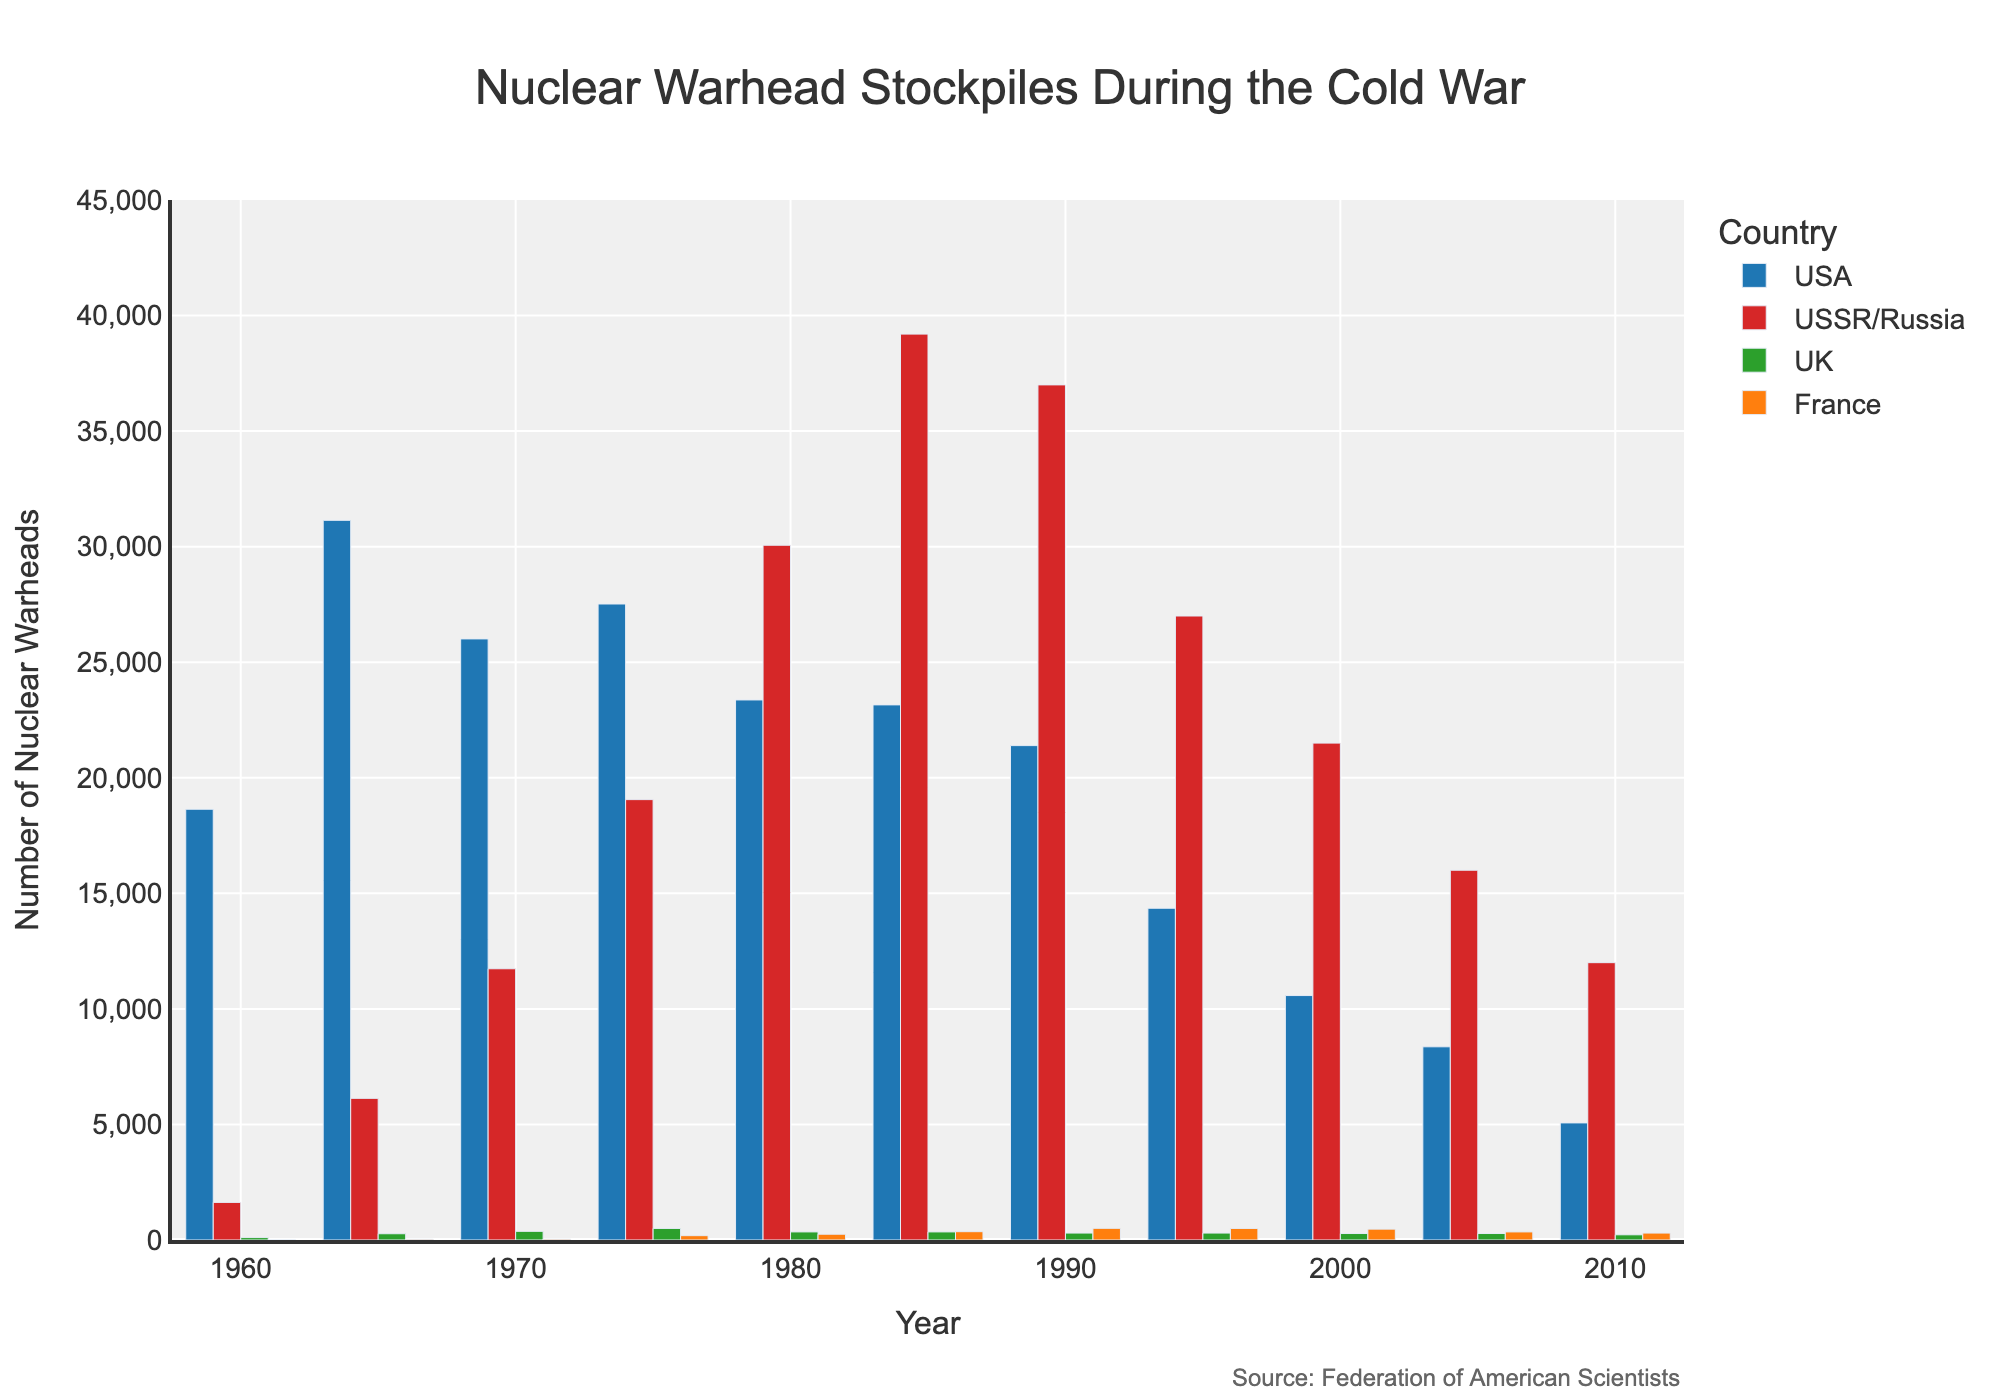What's the highest number of nuclear warheads possessed by the USA and in what year? From the bar chart, look for the tallest bar representing the USA and note the year it corresponds to. The tallest bar for the USA appears in 1965 with 31,139 warheads.
Answer: 1965 In which decade did the Soviet Union/Russia's nuclear warhead count peak? By visually examining the heights of the bars representing the USSR/Russia, the highest point is reached in the 1980s, particularly in 1985 with 39,197 warheads.
Answer: 1980s How did the nuclear arsenal of France change from 1975 to 1985? Observe the heights of the bars for France in 1975 (188 warheads) and in 1985 (360 warheads). Calculate the difference, which is 360 - 188.
Answer: Increased by 172 warheads Between 1960 and 2010, which country showed a consistent decrease in its nuclear warheads? Examine the trends shown by the heights of the bars for all countries over the years. The USA shows a consistent overall decrease from its peak.
Answer: USA Which country had the smallest nuclear arsenal in 1960? Compare the heights of the bars for all countries in 1960. The UK had the smallest nuclear arsenal with 105 warheads.
Answer: UK What was the combined total of nuclear warheads possessed by the USA and the USSR/Russia in 1980? Sum the number of warheads for the USA (23,368) and the USSR/Russia (30,062) in 1980. The total is 23,368 + 30,062.
Answer: 53,430 Which country saw the largest drop in nuclear warheads from 2000 to 2005? Compare the drop in the heights of the bars for each country between 2000 and 2005. The USSR/Russia had the largest drop from 21,500 to 16,000, a difference of 5,500 warheads.
Answer: USSR/Russia How many times greater was the number of warheads in the USSR/Russia compared to the UK in 1975? Divide the number of warheads in the USSR/Russia (19,055) by the number of warheads in the UK (500) for 1975. 19,055 / 500 = 38.11
Answer: About 38 times Which country’s stockpile was closest to 10,000 warheads in 2000? Look at the heights of the bars in 2000. The USA's stockpile was 10,577, which is closest to 10,000, compared to the other nations.
Answer: USA How much did the UK’s nuclear arsenal change between 1960 and 2010? Look at the bars for the UK in 1960 (105 warheads) and in 2010 (225 warheads). Calculate the change, which is 225 - 105.
Answer: Increased by 120 warheads 